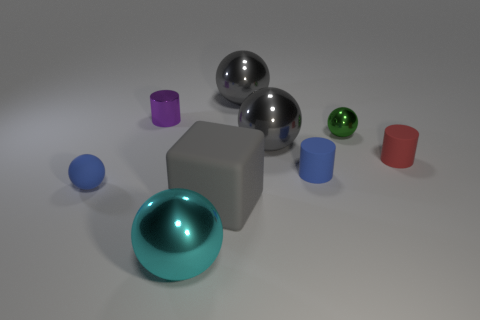How could the lighting and shadows in this image inform us about the setting? The soft shadows and the diffused lighting suggest a scene either illuminated by ambient light or by a non-directional light source, possibly in an indoor setting. It creates a neutral environment which is often used in product visualization to avoid distracting elements and to focus on the objects themselves. 